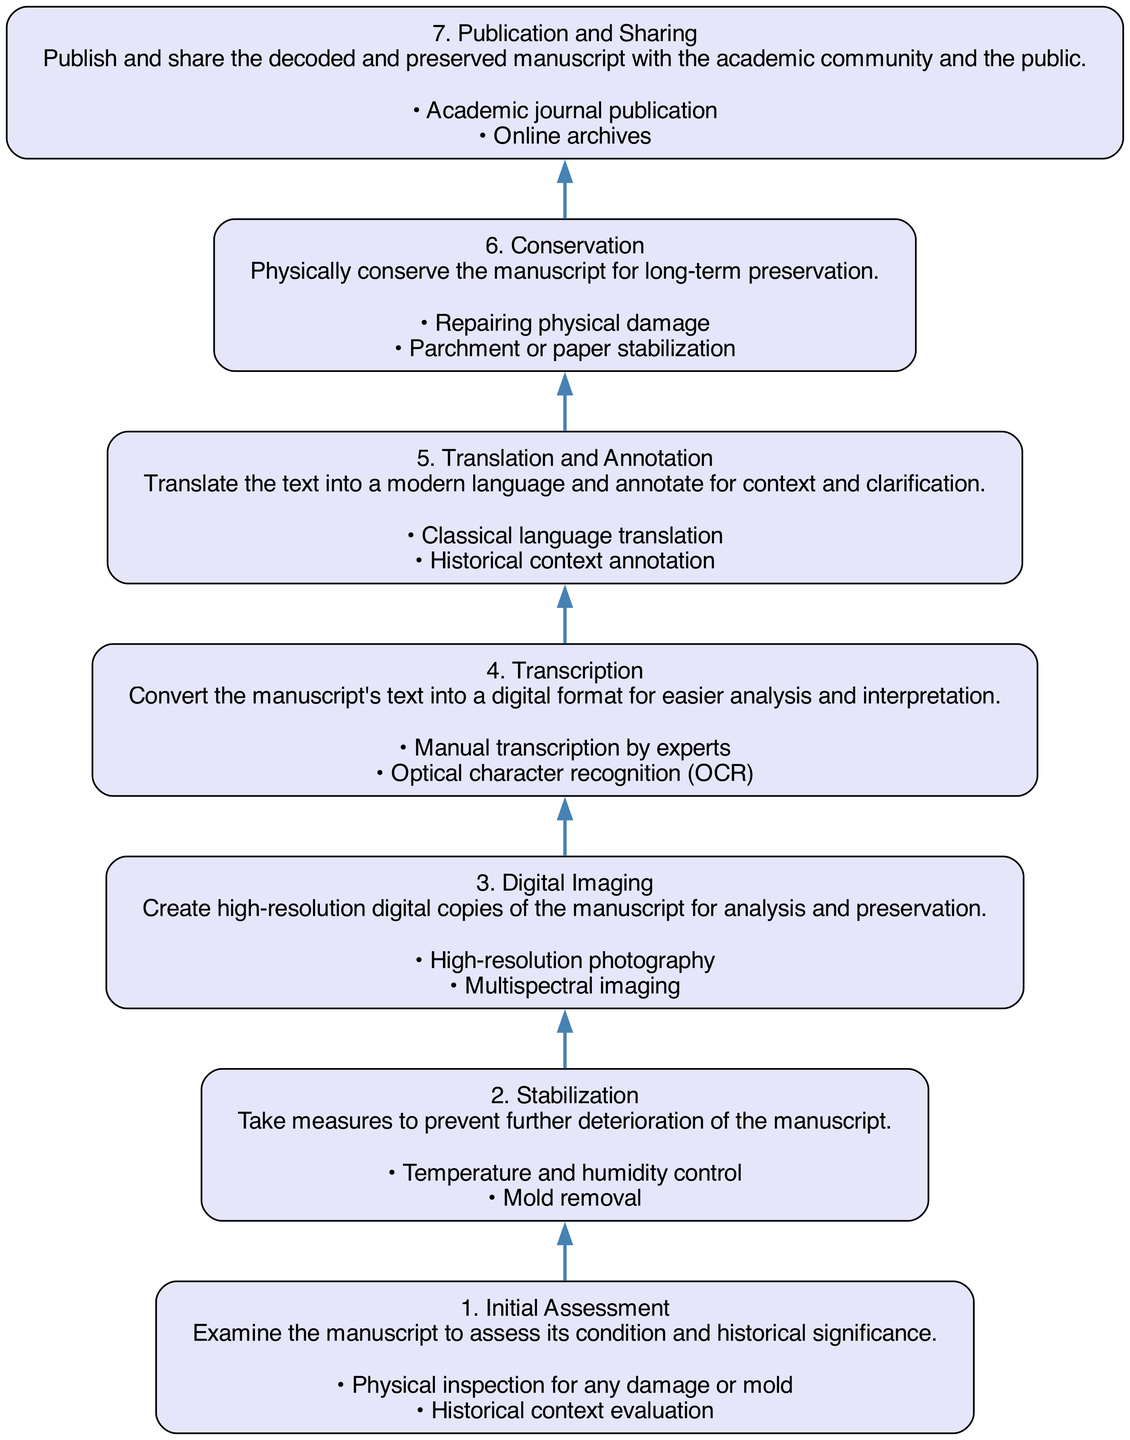What is the first step in the diagram? The first step in the diagram is labeled as "1. Initial Assessment", which is the starting point for the decoding and preservation process of the manuscript.
Answer: Initial Assessment How many total steps are there in the diagram? The diagram consists of seven distinct steps that guide the process from assessment through to publication and sharing.
Answer: 7 What is the step before "Digital Imaging"? The step prior to "Digital Imaging" is "Stabilization", which focuses on taking measures to prevent further deterioration before creating digital copies.
Answer: Stabilization What activities are involved in the "Conservation" step? The activities involved in the "Conservation" step are "Repairing physical damage" and "Parchment or paper stabilization", both crucial for preserving the manuscript physically.
Answer: Repairing physical damage, Parchment or paper stabilization What type of imaging is used in the "Digital Imaging" step? The type of imaging used in the "Digital Imaging" step includes "High-resolution photography" and "Multispectral imaging", both ways to capture detailed digital copies of the manuscript.
Answer: High-resolution photography, Multispectral imaging What action follows the "Transcription" step? The action that follows "Transcription" is "Translation and Annotation", meaning after converting the text, it is then translated and annotated for clarity and context.
Answer: Translation and Annotation Which step involves analyzing historical context? The step that involves analyzing historical context is the "Initial Assessment", where the manuscript is examined not just for its physical condition but also its significance in a historical context.
Answer: Initial Assessment What is involved in the "Publication and Sharing" step? The "Publication and Sharing" step involves actions such as "Academic journal publication" and "Online archives", allowing the work to be disseminated to the broader academic community and the public.
Answer: Academic journal publication, Online archives 